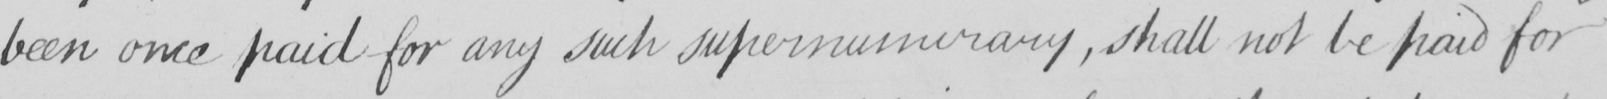What is written in this line of handwriting? been once paid for any such supernumerary  , shall not be paid for 